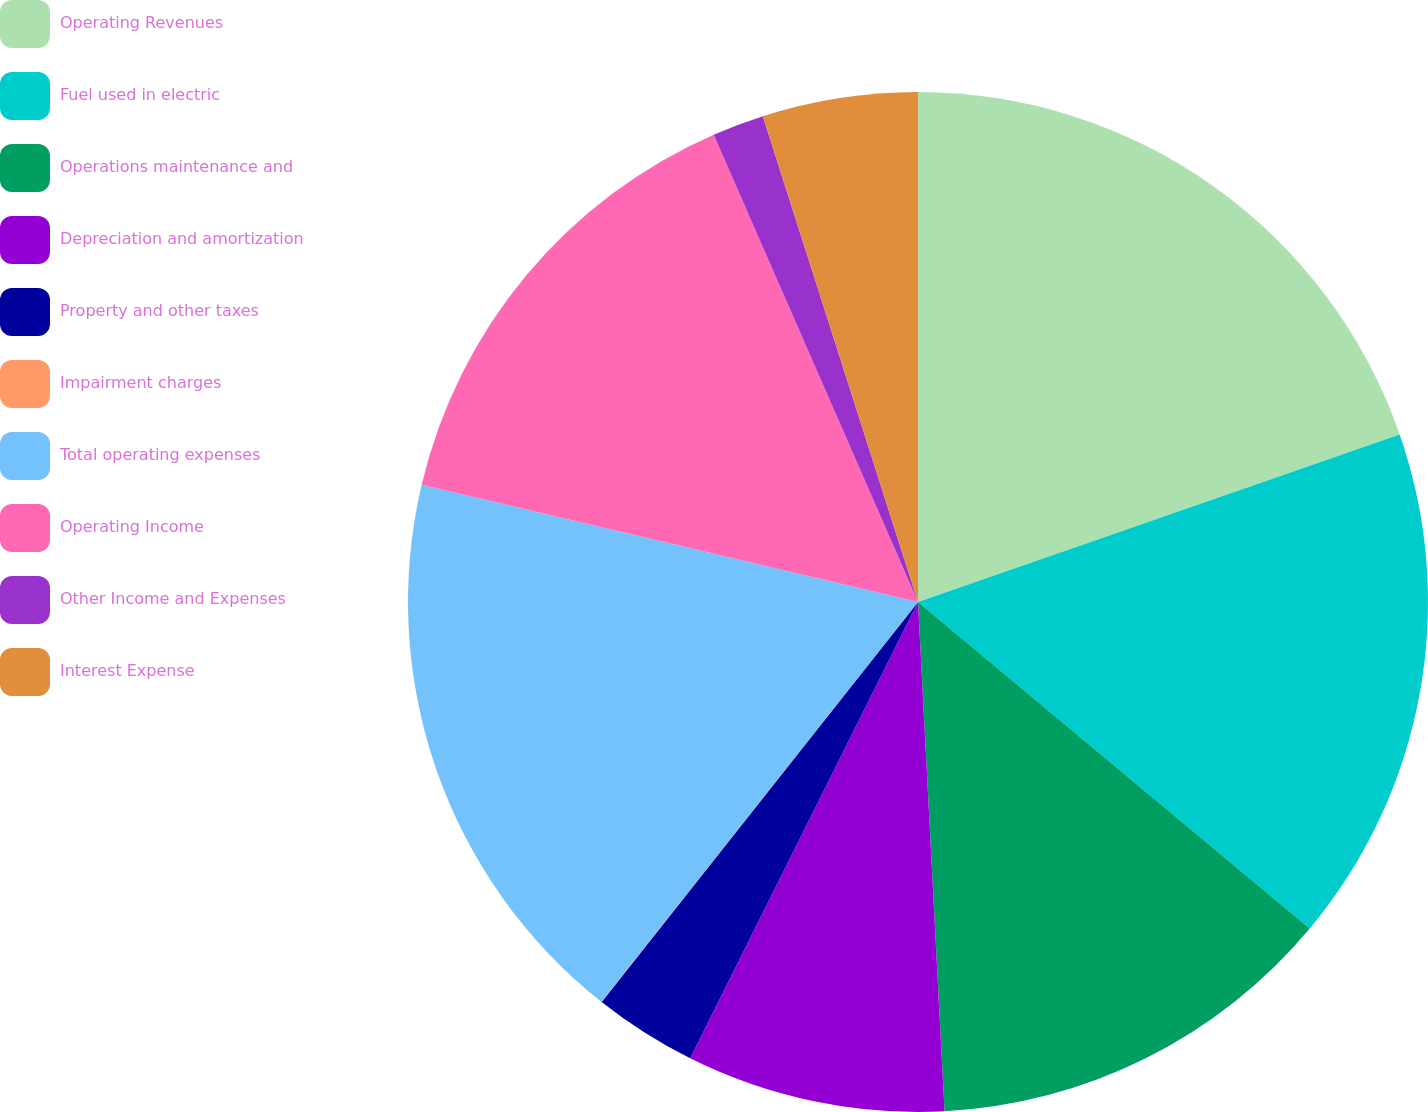Convert chart. <chart><loc_0><loc_0><loc_500><loc_500><pie_chart><fcel>Operating Revenues<fcel>Fuel used in electric<fcel>Operations maintenance and<fcel>Depreciation and amortization<fcel>Property and other taxes<fcel>Impairment charges<fcel>Total operating expenses<fcel>Operating Income<fcel>Other Income and Expenses<fcel>Interest Expense<nl><fcel>19.67%<fcel>16.39%<fcel>13.11%<fcel>8.2%<fcel>3.28%<fcel>0.01%<fcel>18.03%<fcel>14.75%<fcel>1.64%<fcel>4.92%<nl></chart> 